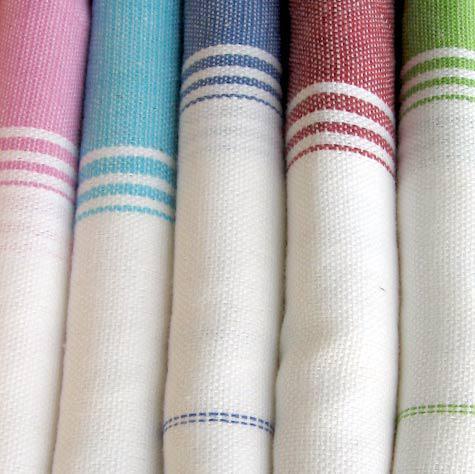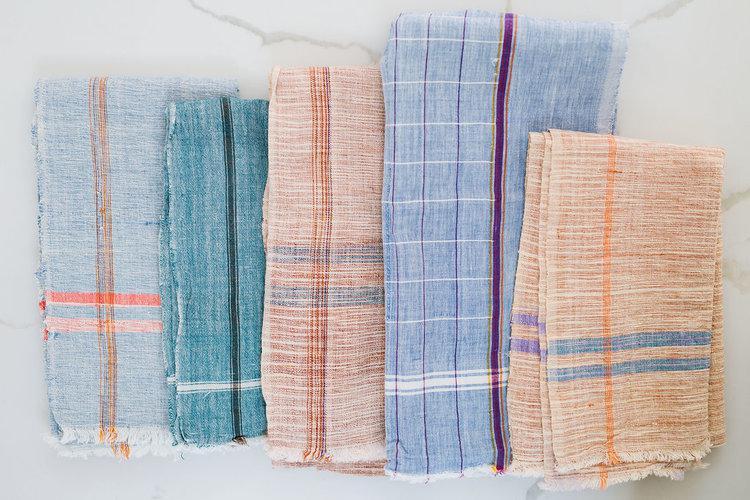The first image is the image on the left, the second image is the image on the right. Considering the images on both sides, is "In at least one image there are three hanging pieces of fabric in the bathroom." valid? Answer yes or no. No. The first image is the image on the left, the second image is the image on the right. Considering the images on both sides, is "One image shows flat, folded, overlapping cloths, and the other image shows the folded edges of white towels, each with differnt colored stripes." valid? Answer yes or no. Yes. 